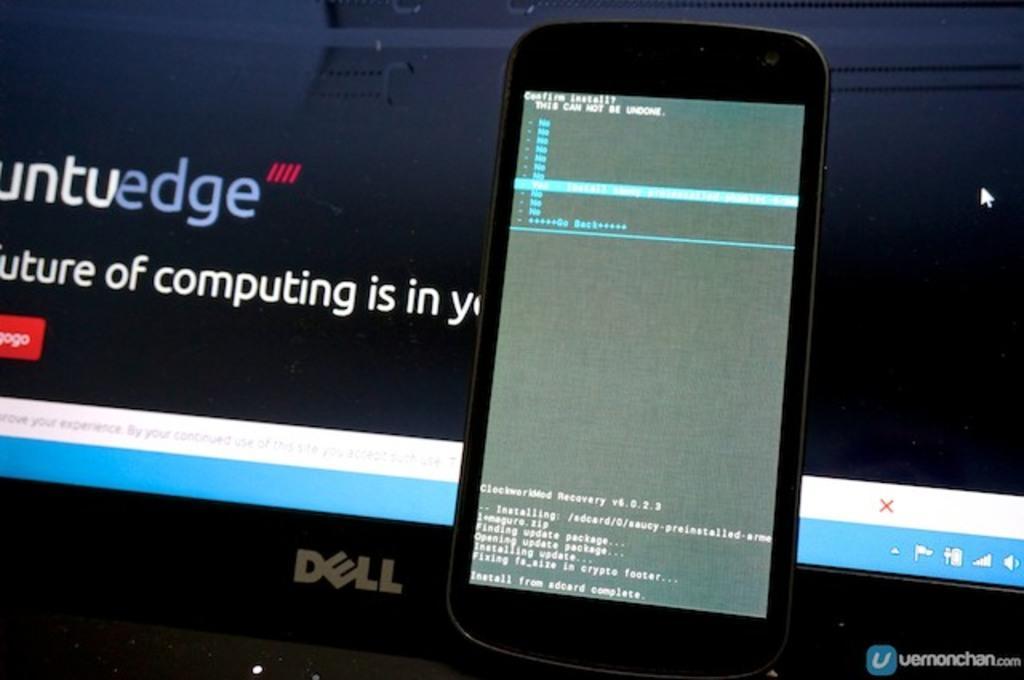Could you give a brief overview of what you see in this image? In this image there is a mobile on the laptop. In the background there is a screen. 